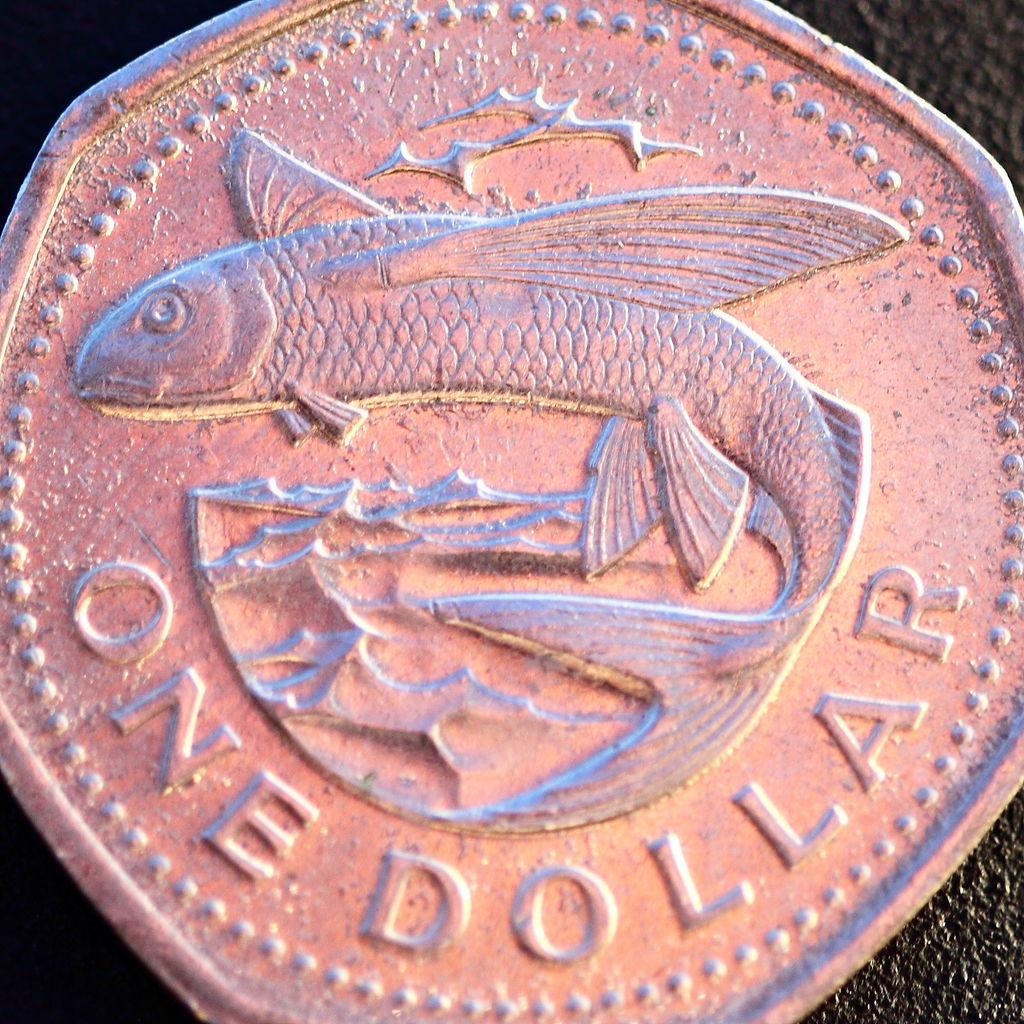<image>
Provide a brief description of the given image. Copper coin that shows a fish and the words ONE DOLLAR. 